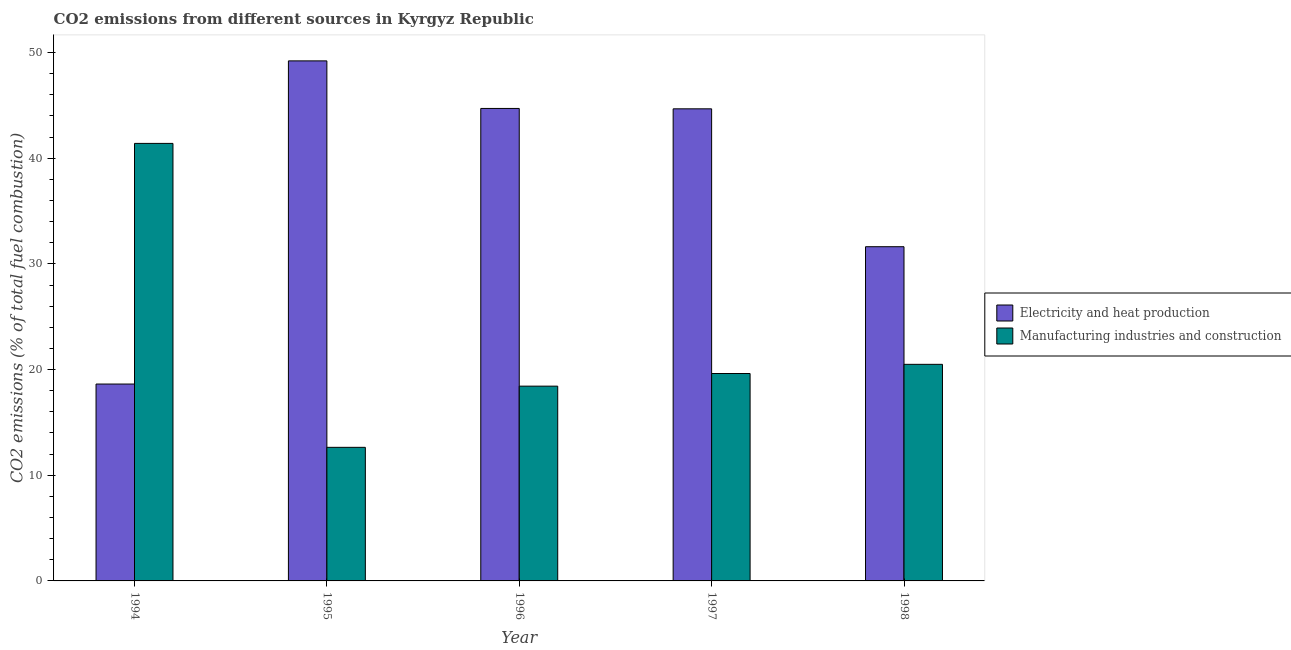How many groups of bars are there?
Give a very brief answer. 5. Are the number of bars per tick equal to the number of legend labels?
Make the answer very short. Yes. Are the number of bars on each tick of the X-axis equal?
Your answer should be very brief. Yes. What is the label of the 1st group of bars from the left?
Keep it short and to the point. 1994. In how many cases, is the number of bars for a given year not equal to the number of legend labels?
Offer a terse response. 0. What is the co2 emissions due to electricity and heat production in 1996?
Provide a succinct answer. 44.71. Across all years, what is the maximum co2 emissions due to manufacturing industries?
Give a very brief answer. 41.4. Across all years, what is the minimum co2 emissions due to manufacturing industries?
Offer a very short reply. 12.64. In which year was the co2 emissions due to electricity and heat production minimum?
Make the answer very short. 1994. What is the total co2 emissions due to manufacturing industries in the graph?
Your response must be concise. 112.59. What is the difference between the co2 emissions due to electricity and heat production in 1995 and that in 1998?
Make the answer very short. 17.58. What is the difference between the co2 emissions due to electricity and heat production in 1996 and the co2 emissions due to manufacturing industries in 1995?
Your answer should be very brief. -4.5. What is the average co2 emissions due to manufacturing industries per year?
Your answer should be compact. 22.52. In the year 1998, what is the difference between the co2 emissions due to manufacturing industries and co2 emissions due to electricity and heat production?
Your answer should be compact. 0. What is the ratio of the co2 emissions due to electricity and heat production in 1996 to that in 1997?
Your answer should be very brief. 1. Is the co2 emissions due to manufacturing industries in 1995 less than that in 1996?
Keep it short and to the point. Yes. What is the difference between the highest and the second highest co2 emissions due to manufacturing industries?
Keep it short and to the point. 20.91. What is the difference between the highest and the lowest co2 emissions due to electricity and heat production?
Provide a short and direct response. 30.58. Is the sum of the co2 emissions due to manufacturing industries in 1996 and 1997 greater than the maximum co2 emissions due to electricity and heat production across all years?
Your answer should be very brief. No. What does the 2nd bar from the left in 1995 represents?
Provide a short and direct response. Manufacturing industries and construction. What does the 1st bar from the right in 1994 represents?
Your response must be concise. Manufacturing industries and construction. Are all the bars in the graph horizontal?
Ensure brevity in your answer.  No. How many years are there in the graph?
Your answer should be compact. 5. Does the graph contain any zero values?
Provide a short and direct response. No. Does the graph contain grids?
Keep it short and to the point. No. How are the legend labels stacked?
Provide a succinct answer. Vertical. What is the title of the graph?
Offer a very short reply. CO2 emissions from different sources in Kyrgyz Republic. What is the label or title of the Y-axis?
Your answer should be very brief. CO2 emissions (% of total fuel combustion). What is the CO2 emissions (% of total fuel combustion) of Electricity and heat production in 1994?
Give a very brief answer. 18.63. What is the CO2 emissions (% of total fuel combustion) of Manufacturing industries and construction in 1994?
Provide a short and direct response. 41.4. What is the CO2 emissions (% of total fuel combustion) in Electricity and heat production in 1995?
Ensure brevity in your answer.  49.21. What is the CO2 emissions (% of total fuel combustion) of Manufacturing industries and construction in 1995?
Your response must be concise. 12.64. What is the CO2 emissions (% of total fuel combustion) of Electricity and heat production in 1996?
Your answer should be very brief. 44.71. What is the CO2 emissions (% of total fuel combustion) in Manufacturing industries and construction in 1996?
Provide a succinct answer. 18.43. What is the CO2 emissions (% of total fuel combustion) of Electricity and heat production in 1997?
Provide a short and direct response. 44.67. What is the CO2 emissions (% of total fuel combustion) of Manufacturing industries and construction in 1997?
Give a very brief answer. 19.63. What is the CO2 emissions (% of total fuel combustion) of Electricity and heat production in 1998?
Your answer should be compact. 31.63. What is the CO2 emissions (% of total fuel combustion) in Manufacturing industries and construction in 1998?
Make the answer very short. 20.49. Across all years, what is the maximum CO2 emissions (% of total fuel combustion) of Electricity and heat production?
Your answer should be compact. 49.21. Across all years, what is the maximum CO2 emissions (% of total fuel combustion) in Manufacturing industries and construction?
Provide a succinct answer. 41.4. Across all years, what is the minimum CO2 emissions (% of total fuel combustion) in Electricity and heat production?
Give a very brief answer. 18.63. Across all years, what is the minimum CO2 emissions (% of total fuel combustion) in Manufacturing industries and construction?
Keep it short and to the point. 12.64. What is the total CO2 emissions (% of total fuel combustion) in Electricity and heat production in the graph?
Offer a very short reply. 188.85. What is the total CO2 emissions (% of total fuel combustion) of Manufacturing industries and construction in the graph?
Keep it short and to the point. 112.59. What is the difference between the CO2 emissions (% of total fuel combustion) of Electricity and heat production in 1994 and that in 1995?
Your response must be concise. -30.58. What is the difference between the CO2 emissions (% of total fuel combustion) of Manufacturing industries and construction in 1994 and that in 1995?
Provide a short and direct response. 28.76. What is the difference between the CO2 emissions (% of total fuel combustion) in Electricity and heat production in 1994 and that in 1996?
Your answer should be very brief. -26.08. What is the difference between the CO2 emissions (% of total fuel combustion) of Manufacturing industries and construction in 1994 and that in 1996?
Give a very brief answer. 22.97. What is the difference between the CO2 emissions (% of total fuel combustion) of Electricity and heat production in 1994 and that in 1997?
Offer a very short reply. -26.04. What is the difference between the CO2 emissions (% of total fuel combustion) in Manufacturing industries and construction in 1994 and that in 1997?
Offer a terse response. 21.78. What is the difference between the CO2 emissions (% of total fuel combustion) of Electricity and heat production in 1994 and that in 1998?
Offer a terse response. -12.99. What is the difference between the CO2 emissions (% of total fuel combustion) in Manufacturing industries and construction in 1994 and that in 1998?
Your answer should be compact. 20.91. What is the difference between the CO2 emissions (% of total fuel combustion) in Electricity and heat production in 1995 and that in 1996?
Offer a very short reply. 4.5. What is the difference between the CO2 emissions (% of total fuel combustion) of Manufacturing industries and construction in 1995 and that in 1996?
Ensure brevity in your answer.  -5.79. What is the difference between the CO2 emissions (% of total fuel combustion) in Electricity and heat production in 1995 and that in 1997?
Your answer should be very brief. 4.54. What is the difference between the CO2 emissions (% of total fuel combustion) of Manufacturing industries and construction in 1995 and that in 1997?
Your response must be concise. -6.99. What is the difference between the CO2 emissions (% of total fuel combustion) in Electricity and heat production in 1995 and that in 1998?
Make the answer very short. 17.58. What is the difference between the CO2 emissions (% of total fuel combustion) in Manufacturing industries and construction in 1995 and that in 1998?
Your response must be concise. -7.85. What is the difference between the CO2 emissions (% of total fuel combustion) in Electricity and heat production in 1996 and that in 1997?
Offer a very short reply. 0.04. What is the difference between the CO2 emissions (% of total fuel combustion) in Manufacturing industries and construction in 1996 and that in 1997?
Offer a very short reply. -1.2. What is the difference between the CO2 emissions (% of total fuel combustion) of Electricity and heat production in 1996 and that in 1998?
Provide a succinct answer. 13.08. What is the difference between the CO2 emissions (% of total fuel combustion) of Manufacturing industries and construction in 1996 and that in 1998?
Offer a very short reply. -2.06. What is the difference between the CO2 emissions (% of total fuel combustion) in Electricity and heat production in 1997 and that in 1998?
Make the answer very short. 13.05. What is the difference between the CO2 emissions (% of total fuel combustion) of Manufacturing industries and construction in 1997 and that in 1998?
Provide a succinct answer. -0.87. What is the difference between the CO2 emissions (% of total fuel combustion) of Electricity and heat production in 1994 and the CO2 emissions (% of total fuel combustion) of Manufacturing industries and construction in 1995?
Provide a short and direct response. 5.99. What is the difference between the CO2 emissions (% of total fuel combustion) in Electricity and heat production in 1994 and the CO2 emissions (% of total fuel combustion) in Manufacturing industries and construction in 1996?
Give a very brief answer. 0.2. What is the difference between the CO2 emissions (% of total fuel combustion) in Electricity and heat production in 1994 and the CO2 emissions (% of total fuel combustion) in Manufacturing industries and construction in 1997?
Your answer should be very brief. -1. What is the difference between the CO2 emissions (% of total fuel combustion) of Electricity and heat production in 1994 and the CO2 emissions (% of total fuel combustion) of Manufacturing industries and construction in 1998?
Give a very brief answer. -1.86. What is the difference between the CO2 emissions (% of total fuel combustion) in Electricity and heat production in 1995 and the CO2 emissions (% of total fuel combustion) in Manufacturing industries and construction in 1996?
Offer a very short reply. 30.78. What is the difference between the CO2 emissions (% of total fuel combustion) in Electricity and heat production in 1995 and the CO2 emissions (% of total fuel combustion) in Manufacturing industries and construction in 1997?
Your answer should be very brief. 29.58. What is the difference between the CO2 emissions (% of total fuel combustion) of Electricity and heat production in 1995 and the CO2 emissions (% of total fuel combustion) of Manufacturing industries and construction in 1998?
Your answer should be compact. 28.72. What is the difference between the CO2 emissions (% of total fuel combustion) of Electricity and heat production in 1996 and the CO2 emissions (% of total fuel combustion) of Manufacturing industries and construction in 1997?
Your response must be concise. 25.08. What is the difference between the CO2 emissions (% of total fuel combustion) of Electricity and heat production in 1996 and the CO2 emissions (% of total fuel combustion) of Manufacturing industries and construction in 1998?
Your answer should be very brief. 24.21. What is the difference between the CO2 emissions (% of total fuel combustion) in Electricity and heat production in 1997 and the CO2 emissions (% of total fuel combustion) in Manufacturing industries and construction in 1998?
Provide a succinct answer. 24.18. What is the average CO2 emissions (% of total fuel combustion) of Electricity and heat production per year?
Offer a very short reply. 37.77. What is the average CO2 emissions (% of total fuel combustion) in Manufacturing industries and construction per year?
Ensure brevity in your answer.  22.52. In the year 1994, what is the difference between the CO2 emissions (% of total fuel combustion) in Electricity and heat production and CO2 emissions (% of total fuel combustion) in Manufacturing industries and construction?
Offer a very short reply. -22.77. In the year 1995, what is the difference between the CO2 emissions (% of total fuel combustion) of Electricity and heat production and CO2 emissions (% of total fuel combustion) of Manufacturing industries and construction?
Your answer should be very brief. 36.57. In the year 1996, what is the difference between the CO2 emissions (% of total fuel combustion) of Electricity and heat production and CO2 emissions (% of total fuel combustion) of Manufacturing industries and construction?
Provide a succinct answer. 26.28. In the year 1997, what is the difference between the CO2 emissions (% of total fuel combustion) in Electricity and heat production and CO2 emissions (% of total fuel combustion) in Manufacturing industries and construction?
Your response must be concise. 25.05. In the year 1998, what is the difference between the CO2 emissions (% of total fuel combustion) of Electricity and heat production and CO2 emissions (% of total fuel combustion) of Manufacturing industries and construction?
Provide a succinct answer. 11.13. What is the ratio of the CO2 emissions (% of total fuel combustion) of Electricity and heat production in 1994 to that in 1995?
Offer a terse response. 0.38. What is the ratio of the CO2 emissions (% of total fuel combustion) in Manufacturing industries and construction in 1994 to that in 1995?
Offer a very short reply. 3.28. What is the ratio of the CO2 emissions (% of total fuel combustion) in Electricity and heat production in 1994 to that in 1996?
Your response must be concise. 0.42. What is the ratio of the CO2 emissions (% of total fuel combustion) in Manufacturing industries and construction in 1994 to that in 1996?
Make the answer very short. 2.25. What is the ratio of the CO2 emissions (% of total fuel combustion) in Electricity and heat production in 1994 to that in 1997?
Offer a very short reply. 0.42. What is the ratio of the CO2 emissions (% of total fuel combustion) of Manufacturing industries and construction in 1994 to that in 1997?
Your answer should be very brief. 2.11. What is the ratio of the CO2 emissions (% of total fuel combustion) in Electricity and heat production in 1994 to that in 1998?
Ensure brevity in your answer.  0.59. What is the ratio of the CO2 emissions (% of total fuel combustion) of Manufacturing industries and construction in 1994 to that in 1998?
Give a very brief answer. 2.02. What is the ratio of the CO2 emissions (% of total fuel combustion) in Electricity and heat production in 1995 to that in 1996?
Offer a very short reply. 1.1. What is the ratio of the CO2 emissions (% of total fuel combustion) of Manufacturing industries and construction in 1995 to that in 1996?
Your answer should be very brief. 0.69. What is the ratio of the CO2 emissions (% of total fuel combustion) in Electricity and heat production in 1995 to that in 1997?
Your answer should be very brief. 1.1. What is the ratio of the CO2 emissions (% of total fuel combustion) in Manufacturing industries and construction in 1995 to that in 1997?
Offer a very short reply. 0.64. What is the ratio of the CO2 emissions (% of total fuel combustion) of Electricity and heat production in 1995 to that in 1998?
Your response must be concise. 1.56. What is the ratio of the CO2 emissions (% of total fuel combustion) of Manufacturing industries and construction in 1995 to that in 1998?
Offer a very short reply. 0.62. What is the ratio of the CO2 emissions (% of total fuel combustion) of Manufacturing industries and construction in 1996 to that in 1997?
Your answer should be compact. 0.94. What is the ratio of the CO2 emissions (% of total fuel combustion) of Electricity and heat production in 1996 to that in 1998?
Offer a terse response. 1.41. What is the ratio of the CO2 emissions (% of total fuel combustion) in Manufacturing industries and construction in 1996 to that in 1998?
Make the answer very short. 0.9. What is the ratio of the CO2 emissions (% of total fuel combustion) of Electricity and heat production in 1997 to that in 1998?
Offer a terse response. 1.41. What is the ratio of the CO2 emissions (% of total fuel combustion) in Manufacturing industries and construction in 1997 to that in 1998?
Provide a succinct answer. 0.96. What is the difference between the highest and the second highest CO2 emissions (% of total fuel combustion) in Electricity and heat production?
Provide a succinct answer. 4.5. What is the difference between the highest and the second highest CO2 emissions (% of total fuel combustion) in Manufacturing industries and construction?
Provide a short and direct response. 20.91. What is the difference between the highest and the lowest CO2 emissions (% of total fuel combustion) in Electricity and heat production?
Offer a very short reply. 30.58. What is the difference between the highest and the lowest CO2 emissions (% of total fuel combustion) of Manufacturing industries and construction?
Provide a succinct answer. 28.76. 